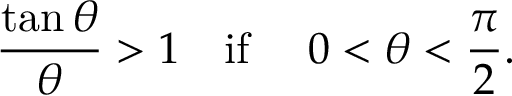<formula> <loc_0><loc_0><loc_500><loc_500>{ \frac { \tan \theta } { \theta } } > 1 \quad i f \quad 0 < \theta < { \frac { \pi } { 2 } } .</formula> 